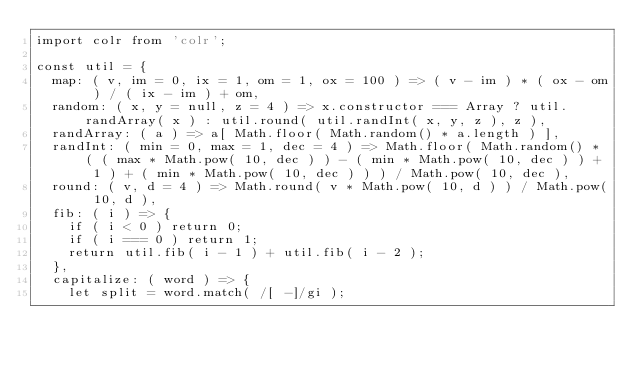<code> <loc_0><loc_0><loc_500><loc_500><_JavaScript_>import colr from 'colr';

const util = {
	map: ( v, im = 0, ix = 1, om = 1, ox = 100 ) => ( v - im ) * ( ox - om ) / ( ix - im ) + om,
	random: ( x, y = null, z = 4 ) => x.constructor === Array ? util.randArray( x ) : util.round( util.randInt( x, y, z ), z ),
	randArray: ( a ) => a[ Math.floor( Math.random() * a.length ) ],
	randInt: ( min = 0, max = 1, dec = 4 ) => Math.floor( Math.random() * ( ( max * Math.pow( 10, dec ) ) - ( min * Math.pow( 10, dec ) ) + 1 ) + ( min * Math.pow( 10, dec ) ) ) / Math.pow( 10, dec ),
	round: ( v, d = 4 ) => Math.round( v * Math.pow( 10, d ) ) / Math.pow( 10, d ),
	fib: ( i ) => {
		if ( i < 0 ) return 0;
		if ( i === 0 ) return 1;
		return util.fib( i - 1 ) + util.fib( i - 2 );
	},
	capitalize: ( word ) => {
		let split = word.match( /[ -]/gi );</code> 